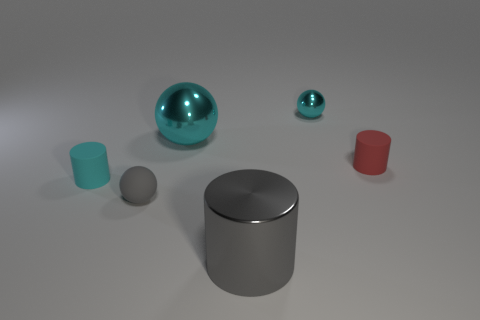Is there any particular pattern or arrangement to how the objects are placed? The objects do not follow a discernible pattern but are arranged with a degree of separation, presenting an orderly distribution across the plane. The variation in sizes and distances creates a sense of depth in the composition. How do the colors of the objects contribute to the overall aesthetic of the image? The cool cyan tones of the spheres are complemented by the neutral gray of the large cylinder, while the contrast provided by the single red cylinder adds visual interest to the scene, creating a balanced yet dynamic color palette. 